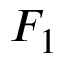<formula> <loc_0><loc_0><loc_500><loc_500>F _ { 1 }</formula> 